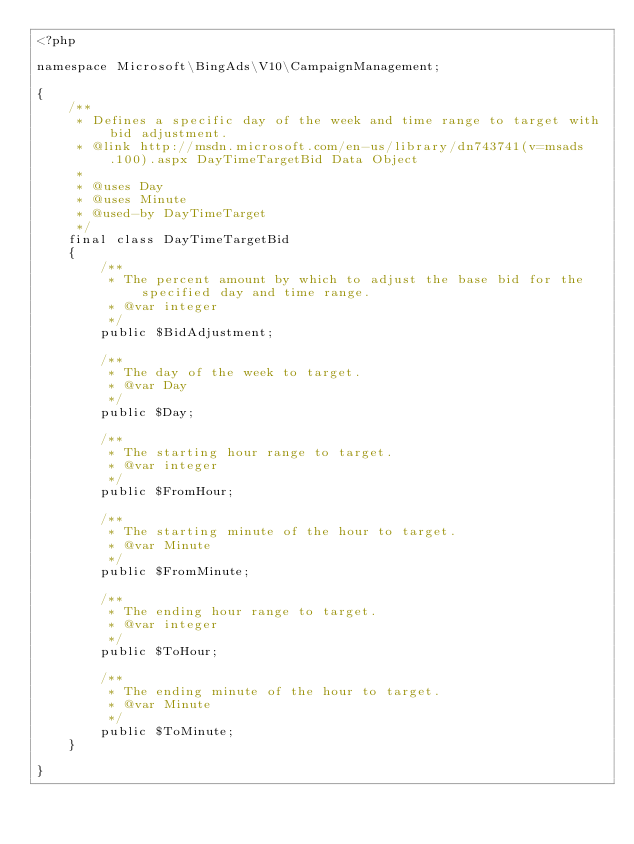Convert code to text. <code><loc_0><loc_0><loc_500><loc_500><_PHP_><?php

namespace Microsoft\BingAds\V10\CampaignManagement;

{
    /**
     * Defines a specific day of the week and time range to target with bid adjustment.
     * @link http://msdn.microsoft.com/en-us/library/dn743741(v=msads.100).aspx DayTimeTargetBid Data Object
     * 
     * @uses Day
     * @uses Minute
     * @used-by DayTimeTarget
     */
    final class DayTimeTargetBid
    {
        /**
         * The percent amount by which to adjust the base bid for the specified day and time range.
         * @var integer
         */
        public $BidAdjustment;

        /**
         * The day of the week to target.
         * @var Day
         */
        public $Day;

        /**
         * The starting hour range to target.
         * @var integer
         */
        public $FromHour;

        /**
         * The starting minute of the hour to target.
         * @var Minute
         */
        public $FromMinute;

        /**
         * The ending hour range to target.
         * @var integer
         */
        public $ToHour;

        /**
         * The ending minute of the hour to target.
         * @var Minute
         */
        public $ToMinute;
    }

}
</code> 